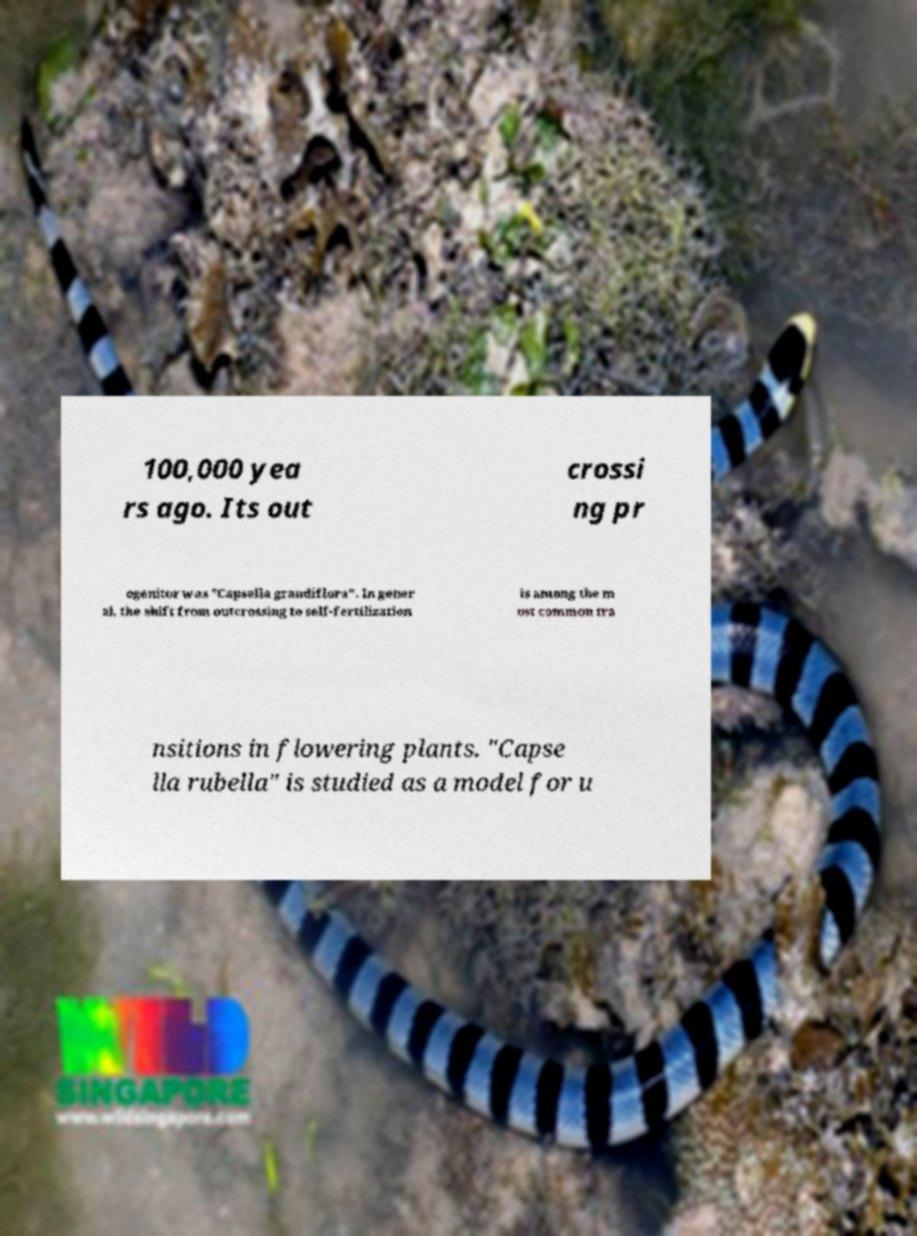Can you read and provide the text displayed in the image?This photo seems to have some interesting text. Can you extract and type it out for me? 100,000 yea rs ago. Its out crossi ng pr ogenitor was "Capsella grandiflora". In gener al, the shift from outcrossing to self-fertilization is among the m ost common tra nsitions in flowering plants. "Capse lla rubella" is studied as a model for u 